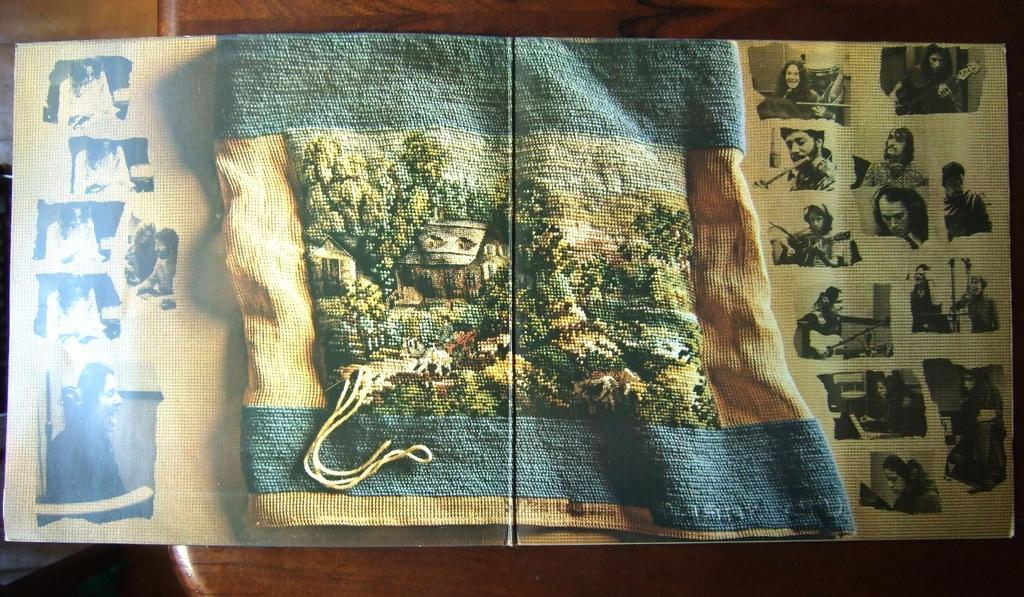What is the main object in the image? There is a puzzle in the image. What can be inferred about the puzzle's location? The puzzle is on a wooden surface. What type of vessel is used to transport the puzzle pieces in the image? There is no vessel present in the image, and the puzzle pieces are already on the wooden surface. 